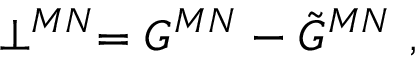<formula> <loc_0><loc_0><loc_500><loc_500>\perp ^ { M N } = G ^ { M N } - \tilde { G } ^ { M N } ,</formula> 